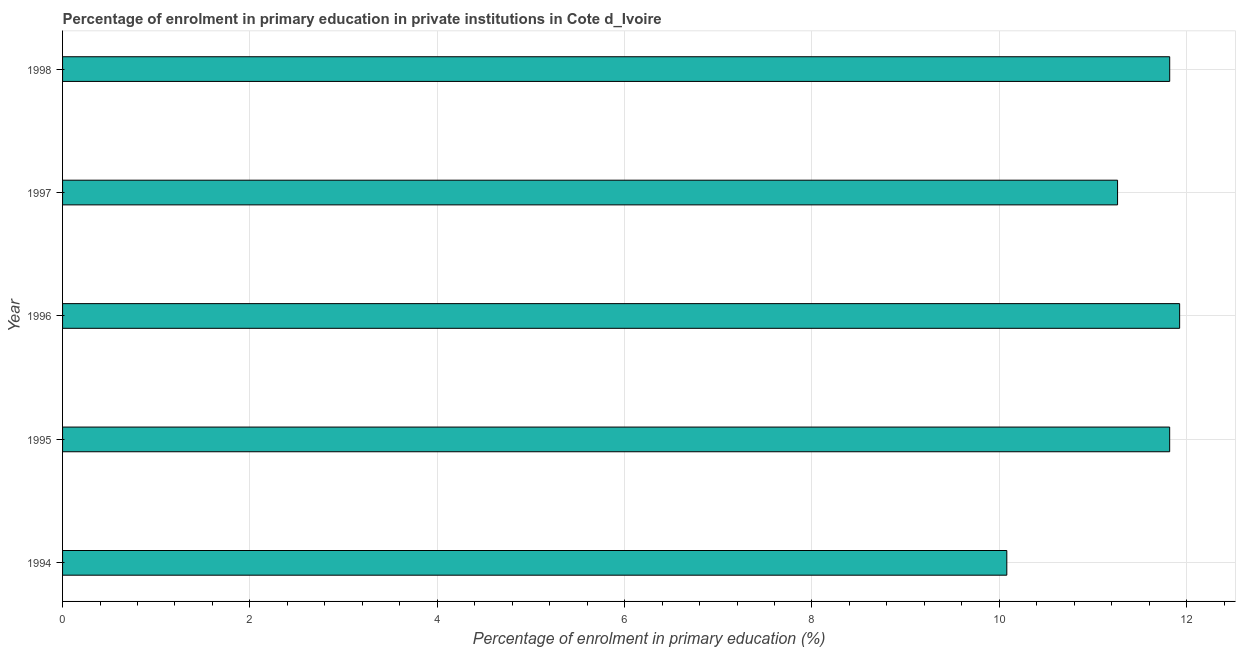Does the graph contain any zero values?
Ensure brevity in your answer.  No. Does the graph contain grids?
Offer a very short reply. Yes. What is the title of the graph?
Your answer should be compact. Percentage of enrolment in primary education in private institutions in Cote d_Ivoire. What is the label or title of the X-axis?
Give a very brief answer. Percentage of enrolment in primary education (%). What is the enrolment percentage in primary education in 1997?
Provide a succinct answer. 11.26. Across all years, what is the maximum enrolment percentage in primary education?
Make the answer very short. 11.93. Across all years, what is the minimum enrolment percentage in primary education?
Your response must be concise. 10.08. What is the sum of the enrolment percentage in primary education?
Provide a short and direct response. 56.91. What is the difference between the enrolment percentage in primary education in 1994 and 1997?
Ensure brevity in your answer.  -1.18. What is the average enrolment percentage in primary education per year?
Provide a succinct answer. 11.38. What is the median enrolment percentage in primary education?
Make the answer very short. 11.82. In how many years, is the enrolment percentage in primary education greater than 8.4 %?
Give a very brief answer. 5. Do a majority of the years between 1994 and 1996 (inclusive) have enrolment percentage in primary education greater than 0.8 %?
Keep it short and to the point. Yes. What is the ratio of the enrolment percentage in primary education in 1995 to that in 1997?
Keep it short and to the point. 1.05. Is the enrolment percentage in primary education in 1994 less than that in 1996?
Your answer should be very brief. Yes. What is the difference between the highest and the second highest enrolment percentage in primary education?
Offer a very short reply. 0.11. What is the difference between the highest and the lowest enrolment percentage in primary education?
Your response must be concise. 1.84. In how many years, is the enrolment percentage in primary education greater than the average enrolment percentage in primary education taken over all years?
Provide a short and direct response. 3. How many bars are there?
Your answer should be compact. 5. How many years are there in the graph?
Your answer should be compact. 5. What is the difference between two consecutive major ticks on the X-axis?
Keep it short and to the point. 2. Are the values on the major ticks of X-axis written in scientific E-notation?
Offer a very short reply. No. What is the Percentage of enrolment in primary education (%) in 1994?
Make the answer very short. 10.08. What is the Percentage of enrolment in primary education (%) in 1995?
Offer a very short reply. 11.82. What is the Percentage of enrolment in primary education (%) of 1996?
Provide a succinct answer. 11.93. What is the Percentage of enrolment in primary education (%) of 1997?
Keep it short and to the point. 11.26. What is the Percentage of enrolment in primary education (%) of 1998?
Provide a short and direct response. 11.82. What is the difference between the Percentage of enrolment in primary education (%) in 1994 and 1995?
Provide a short and direct response. -1.74. What is the difference between the Percentage of enrolment in primary education (%) in 1994 and 1996?
Your answer should be very brief. -1.84. What is the difference between the Percentage of enrolment in primary education (%) in 1994 and 1997?
Your response must be concise. -1.18. What is the difference between the Percentage of enrolment in primary education (%) in 1994 and 1998?
Provide a succinct answer. -1.74. What is the difference between the Percentage of enrolment in primary education (%) in 1995 and 1996?
Give a very brief answer. -0.11. What is the difference between the Percentage of enrolment in primary education (%) in 1995 and 1997?
Provide a succinct answer. 0.56. What is the difference between the Percentage of enrolment in primary education (%) in 1995 and 1998?
Keep it short and to the point. -0. What is the difference between the Percentage of enrolment in primary education (%) in 1996 and 1997?
Your answer should be very brief. 0.66. What is the difference between the Percentage of enrolment in primary education (%) in 1996 and 1998?
Make the answer very short. 0.11. What is the difference between the Percentage of enrolment in primary education (%) in 1997 and 1998?
Make the answer very short. -0.56. What is the ratio of the Percentage of enrolment in primary education (%) in 1994 to that in 1995?
Keep it short and to the point. 0.85. What is the ratio of the Percentage of enrolment in primary education (%) in 1994 to that in 1996?
Your response must be concise. 0.84. What is the ratio of the Percentage of enrolment in primary education (%) in 1994 to that in 1997?
Provide a short and direct response. 0.9. What is the ratio of the Percentage of enrolment in primary education (%) in 1994 to that in 1998?
Provide a short and direct response. 0.85. What is the ratio of the Percentage of enrolment in primary education (%) in 1995 to that in 1997?
Provide a succinct answer. 1.05. What is the ratio of the Percentage of enrolment in primary education (%) in 1995 to that in 1998?
Make the answer very short. 1. What is the ratio of the Percentage of enrolment in primary education (%) in 1996 to that in 1997?
Give a very brief answer. 1.06. What is the ratio of the Percentage of enrolment in primary education (%) in 1996 to that in 1998?
Keep it short and to the point. 1.01. What is the ratio of the Percentage of enrolment in primary education (%) in 1997 to that in 1998?
Give a very brief answer. 0.95. 